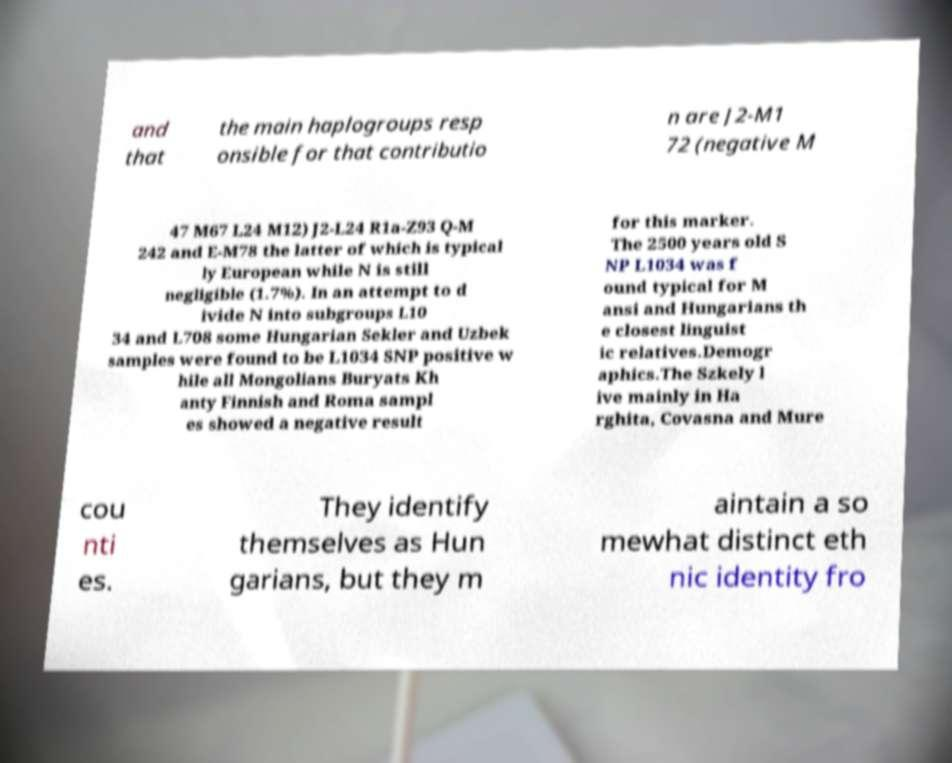Could you assist in decoding the text presented in this image and type it out clearly? and that the main haplogroups resp onsible for that contributio n are J2-M1 72 (negative M 47 M67 L24 M12) J2-L24 R1a-Z93 Q-M 242 and E-M78 the latter of which is typical ly European while N is still negligible (1.7%). In an attempt to d ivide N into subgroups L10 34 and L708 some Hungarian Sekler and Uzbek samples were found to be L1034 SNP positive w hile all Mongolians Buryats Kh anty Finnish and Roma sampl es showed a negative result for this marker. The 2500 years old S NP L1034 was f ound typical for M ansi and Hungarians th e closest linguist ic relatives.Demogr aphics.The Szkely l ive mainly in Ha rghita, Covasna and Mure cou nti es. They identify themselves as Hun garians, but they m aintain a so mewhat distinct eth nic identity fro 